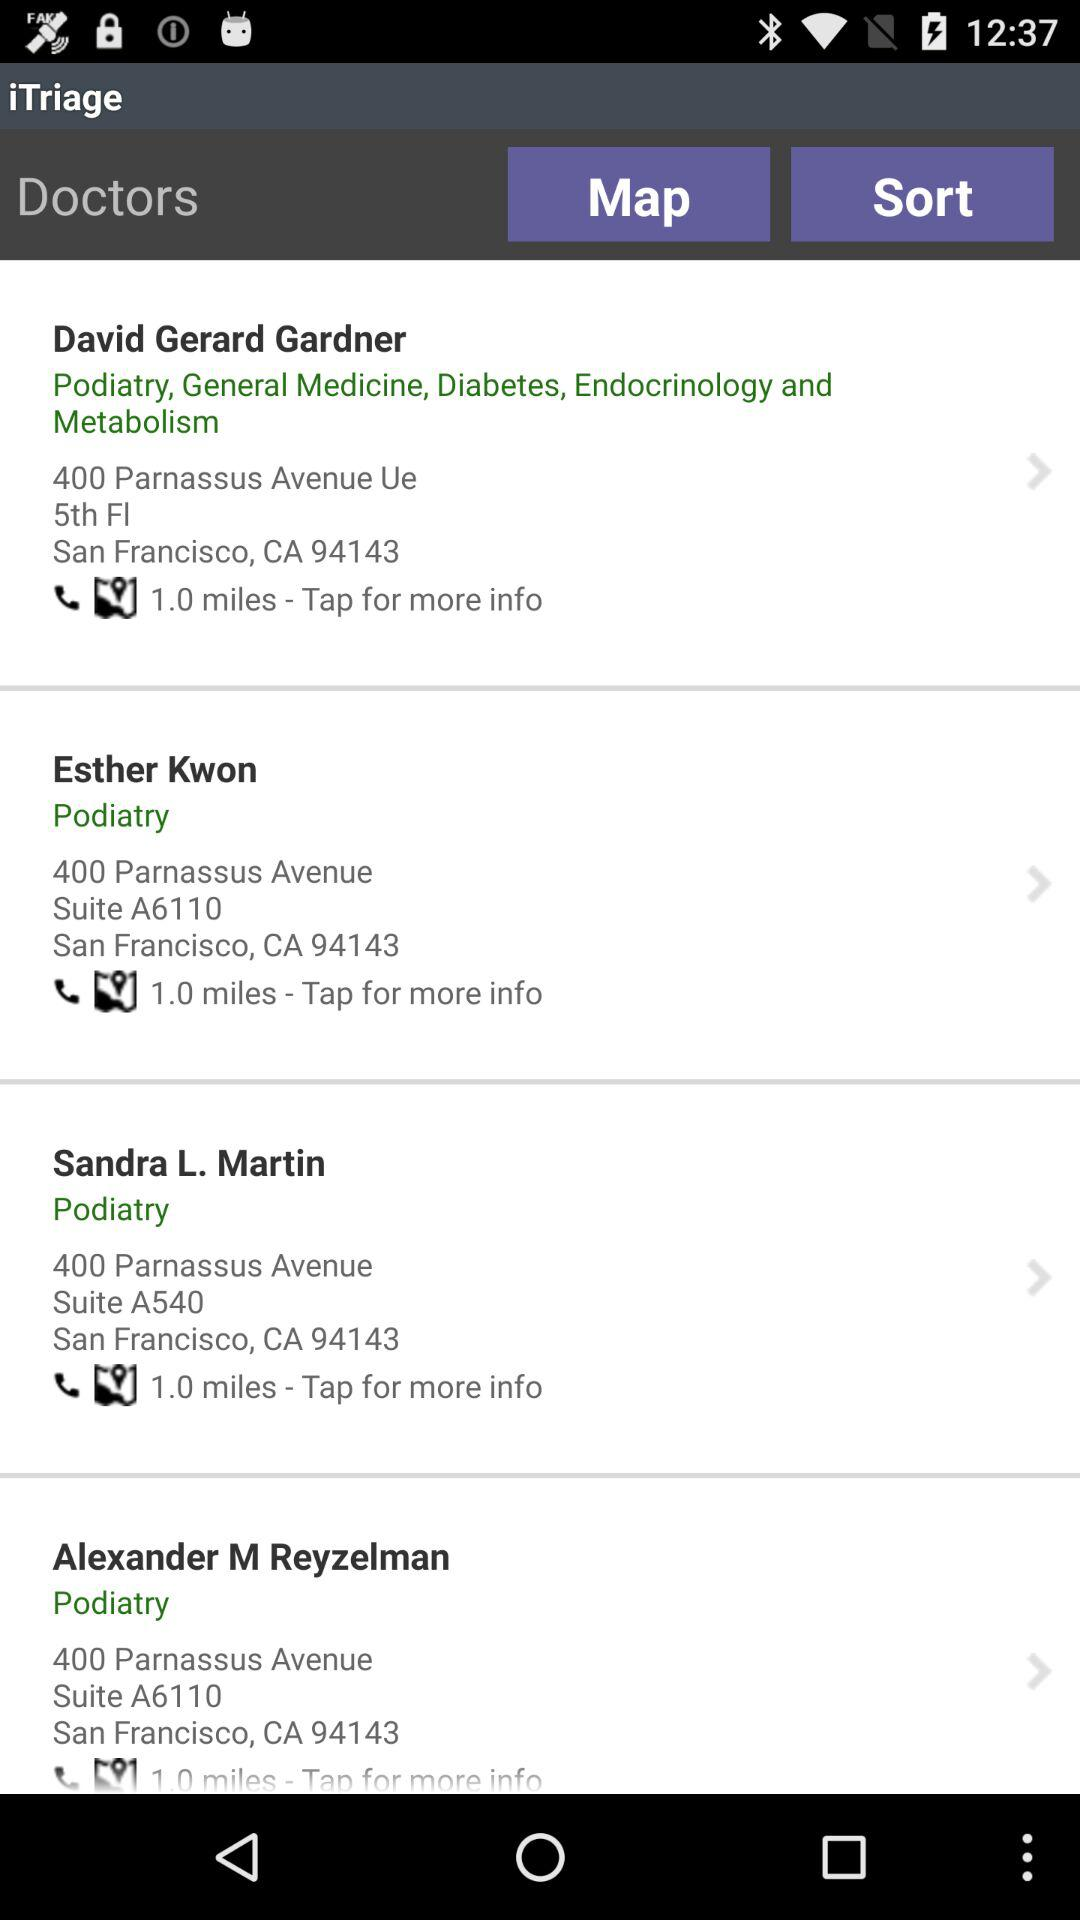What is the address of Esther Kwon? The address of Esther Kwon is 400 Parnassus Avenue, Suite A6110, San Francisco, CA 94143. 